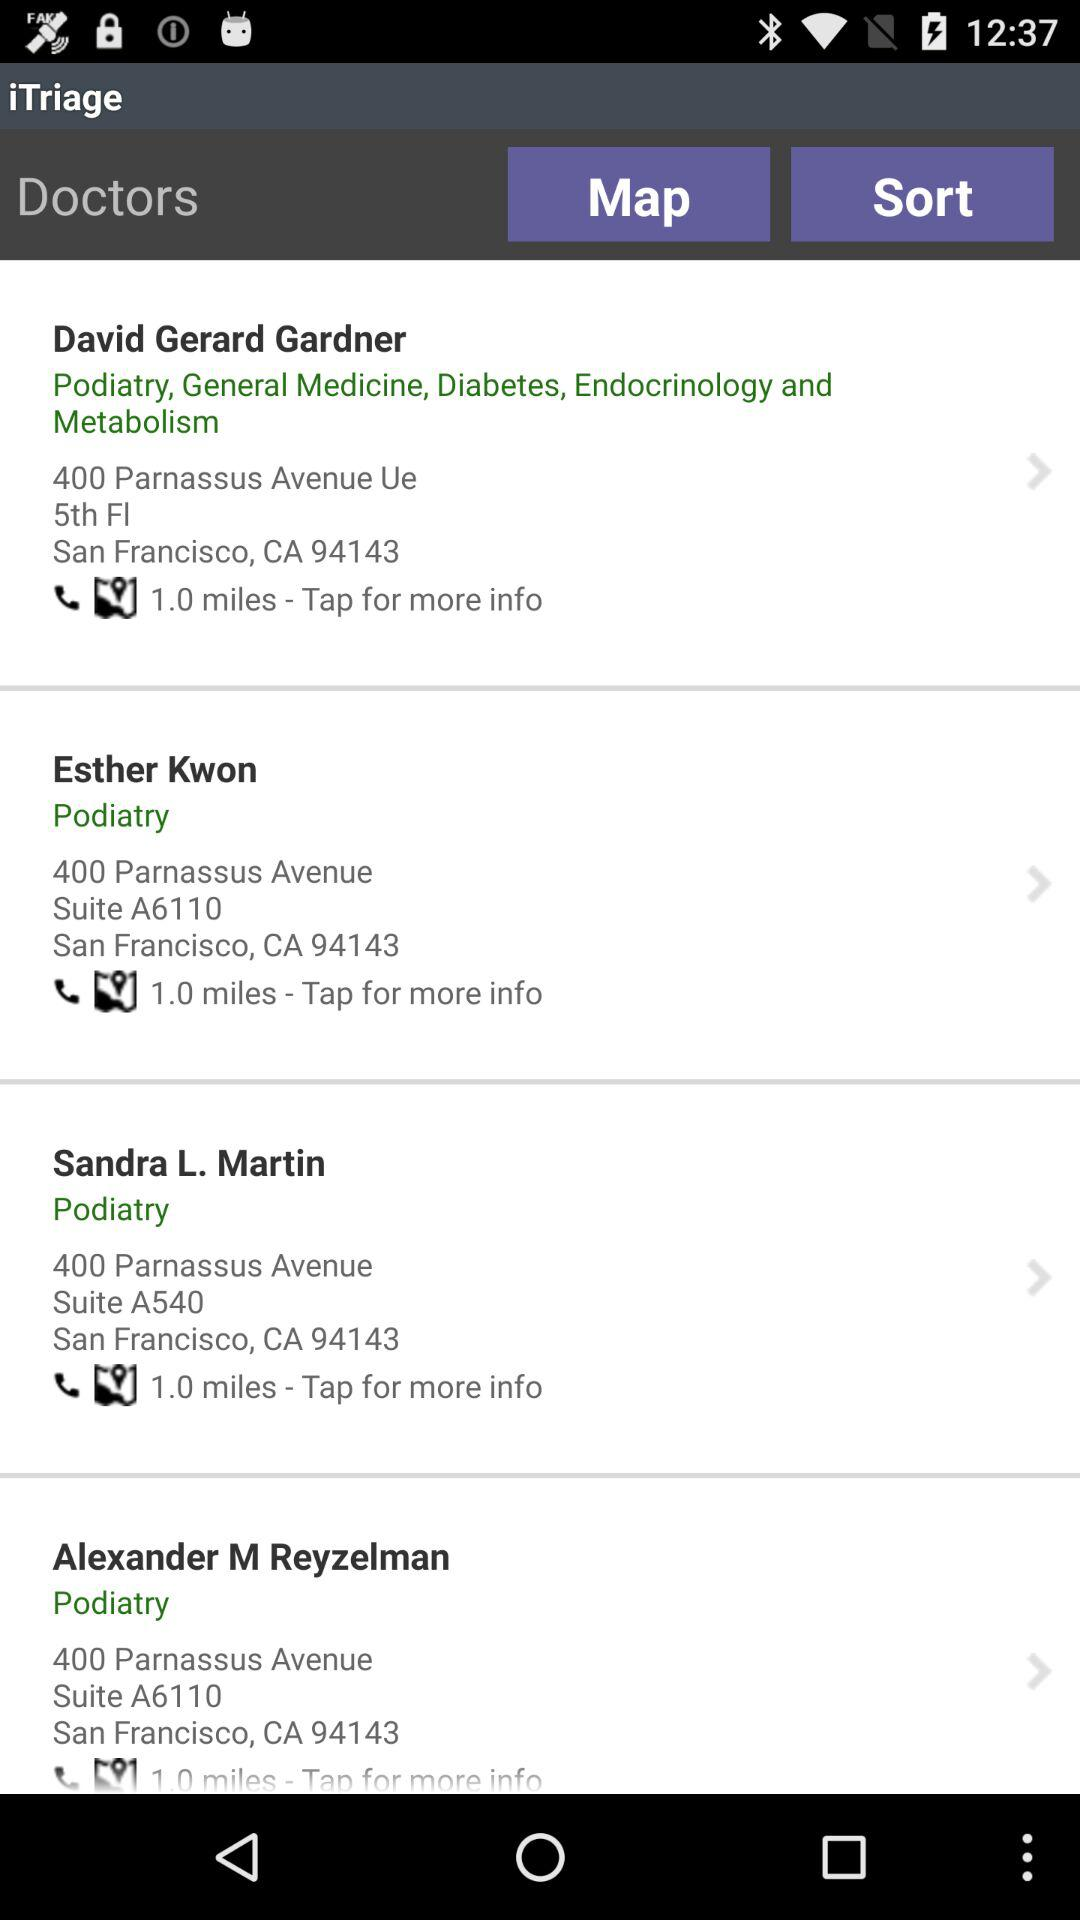What is the address of Esther Kwon? The address of Esther Kwon is 400 Parnassus Avenue, Suite A6110, San Francisco, CA 94143. 